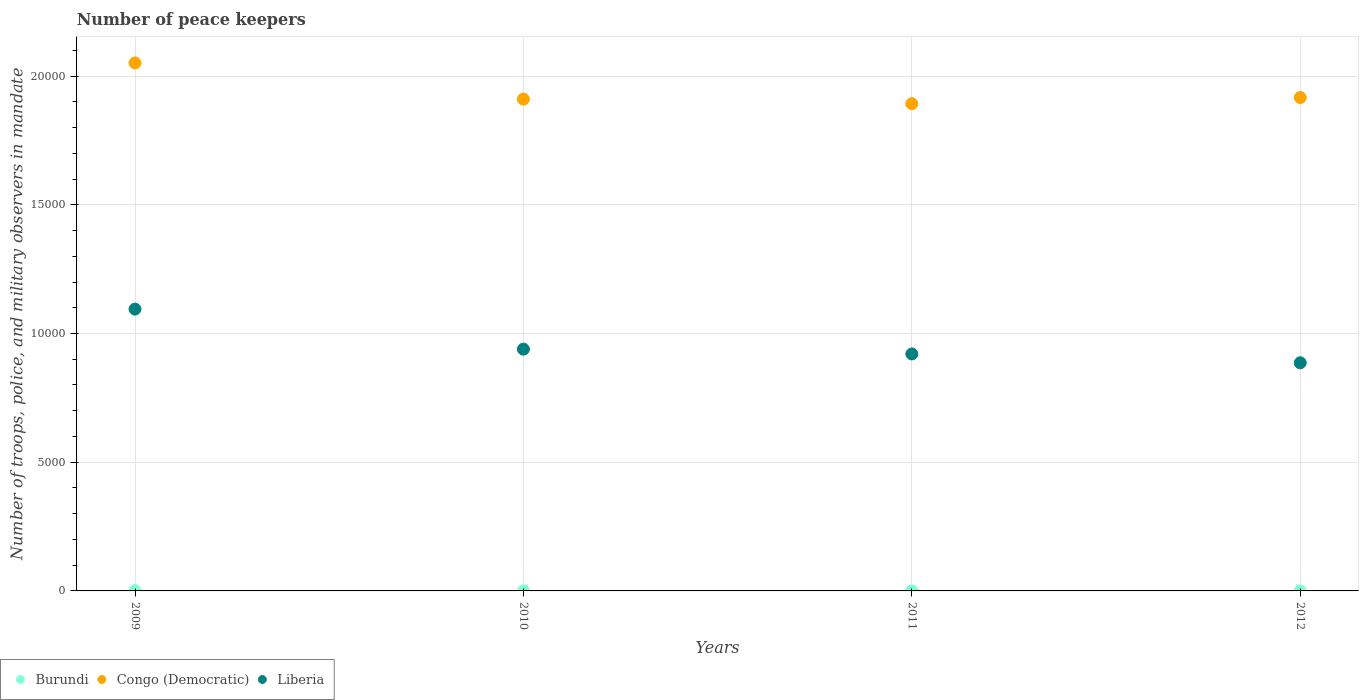Is the number of dotlines equal to the number of legend labels?
Your response must be concise. Yes. Across all years, what is the maximum number of peace keepers in in Liberia?
Provide a short and direct response. 1.09e+04. What is the total number of peace keepers in in Congo (Democratic) in the graph?
Offer a terse response. 7.77e+04. What is the difference between the number of peace keepers in in Burundi in 2009 and that in 2011?
Provide a succinct answer. 14. What is the difference between the number of peace keepers in in Congo (Democratic) in 2011 and the number of peace keepers in in Liberia in 2010?
Provide a short and direct response. 9536. What is the average number of peace keepers in in Congo (Democratic) per year?
Provide a short and direct response. 1.94e+04. In the year 2010, what is the difference between the number of peace keepers in in Burundi and number of peace keepers in in Liberia?
Provide a succinct answer. -9388. What is the ratio of the number of peace keepers in in Congo (Democratic) in 2009 to that in 2011?
Provide a succinct answer. 1.08. Is the number of peace keepers in in Burundi in 2010 less than that in 2012?
Your answer should be very brief. No. Is the difference between the number of peace keepers in in Burundi in 2009 and 2010 greater than the difference between the number of peace keepers in in Liberia in 2009 and 2010?
Provide a short and direct response. No. What is the difference between the highest and the second highest number of peace keepers in in Liberia?
Give a very brief answer. 1555. In how many years, is the number of peace keepers in in Burundi greater than the average number of peace keepers in in Burundi taken over all years?
Offer a terse response. 1. Is the sum of the number of peace keepers in in Liberia in 2011 and 2012 greater than the maximum number of peace keepers in in Congo (Democratic) across all years?
Keep it short and to the point. No. Does the number of peace keepers in in Liberia monotonically increase over the years?
Provide a short and direct response. No. Is the number of peace keepers in in Congo (Democratic) strictly greater than the number of peace keepers in in Burundi over the years?
Provide a short and direct response. Yes. How many dotlines are there?
Provide a short and direct response. 3. How many years are there in the graph?
Give a very brief answer. 4. Are the values on the major ticks of Y-axis written in scientific E-notation?
Keep it short and to the point. No. Does the graph contain grids?
Your answer should be very brief. Yes. How are the legend labels stacked?
Your response must be concise. Horizontal. What is the title of the graph?
Your answer should be very brief. Number of peace keepers. What is the label or title of the Y-axis?
Offer a terse response. Number of troops, police, and military observers in mandate. What is the Number of troops, police, and military observers in mandate of Burundi in 2009?
Keep it short and to the point. 15. What is the Number of troops, police, and military observers in mandate of Congo (Democratic) in 2009?
Provide a short and direct response. 2.05e+04. What is the Number of troops, police, and military observers in mandate of Liberia in 2009?
Keep it short and to the point. 1.09e+04. What is the Number of troops, police, and military observers in mandate of Congo (Democratic) in 2010?
Make the answer very short. 1.91e+04. What is the Number of troops, police, and military observers in mandate of Liberia in 2010?
Your answer should be compact. 9392. What is the Number of troops, police, and military observers in mandate of Congo (Democratic) in 2011?
Offer a terse response. 1.89e+04. What is the Number of troops, police, and military observers in mandate of Liberia in 2011?
Offer a terse response. 9206. What is the Number of troops, police, and military observers in mandate of Congo (Democratic) in 2012?
Your response must be concise. 1.92e+04. What is the Number of troops, police, and military observers in mandate in Liberia in 2012?
Your answer should be very brief. 8862. Across all years, what is the maximum Number of troops, police, and military observers in mandate of Congo (Democratic)?
Ensure brevity in your answer.  2.05e+04. Across all years, what is the maximum Number of troops, police, and military observers in mandate in Liberia?
Your response must be concise. 1.09e+04. Across all years, what is the minimum Number of troops, police, and military observers in mandate in Congo (Democratic)?
Give a very brief answer. 1.89e+04. Across all years, what is the minimum Number of troops, police, and military observers in mandate of Liberia?
Offer a terse response. 8862. What is the total Number of troops, police, and military observers in mandate in Congo (Democratic) in the graph?
Provide a short and direct response. 7.77e+04. What is the total Number of troops, police, and military observers in mandate of Liberia in the graph?
Make the answer very short. 3.84e+04. What is the difference between the Number of troops, police, and military observers in mandate of Congo (Democratic) in 2009 and that in 2010?
Offer a very short reply. 1404. What is the difference between the Number of troops, police, and military observers in mandate of Liberia in 2009 and that in 2010?
Make the answer very short. 1555. What is the difference between the Number of troops, police, and military observers in mandate of Burundi in 2009 and that in 2011?
Provide a succinct answer. 14. What is the difference between the Number of troops, police, and military observers in mandate in Congo (Democratic) in 2009 and that in 2011?
Offer a very short reply. 1581. What is the difference between the Number of troops, police, and military observers in mandate of Liberia in 2009 and that in 2011?
Offer a very short reply. 1741. What is the difference between the Number of troops, police, and military observers in mandate in Congo (Democratic) in 2009 and that in 2012?
Ensure brevity in your answer.  1343. What is the difference between the Number of troops, police, and military observers in mandate of Liberia in 2009 and that in 2012?
Your response must be concise. 2085. What is the difference between the Number of troops, police, and military observers in mandate in Burundi in 2010 and that in 2011?
Your answer should be very brief. 3. What is the difference between the Number of troops, police, and military observers in mandate in Congo (Democratic) in 2010 and that in 2011?
Offer a very short reply. 177. What is the difference between the Number of troops, police, and military observers in mandate in Liberia in 2010 and that in 2011?
Provide a short and direct response. 186. What is the difference between the Number of troops, police, and military observers in mandate in Congo (Democratic) in 2010 and that in 2012?
Ensure brevity in your answer.  -61. What is the difference between the Number of troops, police, and military observers in mandate in Liberia in 2010 and that in 2012?
Provide a succinct answer. 530. What is the difference between the Number of troops, police, and military observers in mandate in Burundi in 2011 and that in 2012?
Provide a short and direct response. -1. What is the difference between the Number of troops, police, and military observers in mandate of Congo (Democratic) in 2011 and that in 2012?
Your answer should be very brief. -238. What is the difference between the Number of troops, police, and military observers in mandate in Liberia in 2011 and that in 2012?
Give a very brief answer. 344. What is the difference between the Number of troops, police, and military observers in mandate of Burundi in 2009 and the Number of troops, police, and military observers in mandate of Congo (Democratic) in 2010?
Your answer should be compact. -1.91e+04. What is the difference between the Number of troops, police, and military observers in mandate in Burundi in 2009 and the Number of troops, police, and military observers in mandate in Liberia in 2010?
Your answer should be compact. -9377. What is the difference between the Number of troops, police, and military observers in mandate in Congo (Democratic) in 2009 and the Number of troops, police, and military observers in mandate in Liberia in 2010?
Provide a succinct answer. 1.11e+04. What is the difference between the Number of troops, police, and military observers in mandate of Burundi in 2009 and the Number of troops, police, and military observers in mandate of Congo (Democratic) in 2011?
Provide a succinct answer. -1.89e+04. What is the difference between the Number of troops, police, and military observers in mandate of Burundi in 2009 and the Number of troops, police, and military observers in mandate of Liberia in 2011?
Provide a succinct answer. -9191. What is the difference between the Number of troops, police, and military observers in mandate in Congo (Democratic) in 2009 and the Number of troops, police, and military observers in mandate in Liberia in 2011?
Your response must be concise. 1.13e+04. What is the difference between the Number of troops, police, and military observers in mandate of Burundi in 2009 and the Number of troops, police, and military observers in mandate of Congo (Democratic) in 2012?
Offer a very short reply. -1.92e+04. What is the difference between the Number of troops, police, and military observers in mandate of Burundi in 2009 and the Number of troops, police, and military observers in mandate of Liberia in 2012?
Your answer should be compact. -8847. What is the difference between the Number of troops, police, and military observers in mandate of Congo (Democratic) in 2009 and the Number of troops, police, and military observers in mandate of Liberia in 2012?
Ensure brevity in your answer.  1.16e+04. What is the difference between the Number of troops, police, and military observers in mandate of Burundi in 2010 and the Number of troops, police, and military observers in mandate of Congo (Democratic) in 2011?
Provide a short and direct response. -1.89e+04. What is the difference between the Number of troops, police, and military observers in mandate in Burundi in 2010 and the Number of troops, police, and military observers in mandate in Liberia in 2011?
Your response must be concise. -9202. What is the difference between the Number of troops, police, and military observers in mandate in Congo (Democratic) in 2010 and the Number of troops, police, and military observers in mandate in Liberia in 2011?
Provide a short and direct response. 9899. What is the difference between the Number of troops, police, and military observers in mandate in Burundi in 2010 and the Number of troops, police, and military observers in mandate in Congo (Democratic) in 2012?
Your response must be concise. -1.92e+04. What is the difference between the Number of troops, police, and military observers in mandate of Burundi in 2010 and the Number of troops, police, and military observers in mandate of Liberia in 2012?
Make the answer very short. -8858. What is the difference between the Number of troops, police, and military observers in mandate in Congo (Democratic) in 2010 and the Number of troops, police, and military observers in mandate in Liberia in 2012?
Make the answer very short. 1.02e+04. What is the difference between the Number of troops, police, and military observers in mandate of Burundi in 2011 and the Number of troops, police, and military observers in mandate of Congo (Democratic) in 2012?
Offer a terse response. -1.92e+04. What is the difference between the Number of troops, police, and military observers in mandate of Burundi in 2011 and the Number of troops, police, and military observers in mandate of Liberia in 2012?
Offer a very short reply. -8861. What is the difference between the Number of troops, police, and military observers in mandate in Congo (Democratic) in 2011 and the Number of troops, police, and military observers in mandate in Liberia in 2012?
Your answer should be very brief. 1.01e+04. What is the average Number of troops, police, and military observers in mandate in Burundi per year?
Your response must be concise. 5.5. What is the average Number of troops, police, and military observers in mandate in Congo (Democratic) per year?
Make the answer very short. 1.94e+04. What is the average Number of troops, police, and military observers in mandate of Liberia per year?
Your response must be concise. 9601.75. In the year 2009, what is the difference between the Number of troops, police, and military observers in mandate of Burundi and Number of troops, police, and military observers in mandate of Congo (Democratic)?
Provide a succinct answer. -2.05e+04. In the year 2009, what is the difference between the Number of troops, police, and military observers in mandate in Burundi and Number of troops, police, and military observers in mandate in Liberia?
Give a very brief answer. -1.09e+04. In the year 2009, what is the difference between the Number of troops, police, and military observers in mandate in Congo (Democratic) and Number of troops, police, and military observers in mandate in Liberia?
Keep it short and to the point. 9562. In the year 2010, what is the difference between the Number of troops, police, and military observers in mandate of Burundi and Number of troops, police, and military observers in mandate of Congo (Democratic)?
Your answer should be compact. -1.91e+04. In the year 2010, what is the difference between the Number of troops, police, and military observers in mandate of Burundi and Number of troops, police, and military observers in mandate of Liberia?
Provide a succinct answer. -9388. In the year 2010, what is the difference between the Number of troops, police, and military observers in mandate in Congo (Democratic) and Number of troops, police, and military observers in mandate in Liberia?
Provide a short and direct response. 9713. In the year 2011, what is the difference between the Number of troops, police, and military observers in mandate of Burundi and Number of troops, police, and military observers in mandate of Congo (Democratic)?
Give a very brief answer. -1.89e+04. In the year 2011, what is the difference between the Number of troops, police, and military observers in mandate in Burundi and Number of troops, police, and military observers in mandate in Liberia?
Provide a short and direct response. -9205. In the year 2011, what is the difference between the Number of troops, police, and military observers in mandate of Congo (Democratic) and Number of troops, police, and military observers in mandate of Liberia?
Ensure brevity in your answer.  9722. In the year 2012, what is the difference between the Number of troops, police, and military observers in mandate of Burundi and Number of troops, police, and military observers in mandate of Congo (Democratic)?
Offer a very short reply. -1.92e+04. In the year 2012, what is the difference between the Number of troops, police, and military observers in mandate in Burundi and Number of troops, police, and military observers in mandate in Liberia?
Your response must be concise. -8860. In the year 2012, what is the difference between the Number of troops, police, and military observers in mandate in Congo (Democratic) and Number of troops, police, and military observers in mandate in Liberia?
Ensure brevity in your answer.  1.03e+04. What is the ratio of the Number of troops, police, and military observers in mandate in Burundi in 2009 to that in 2010?
Your answer should be very brief. 3.75. What is the ratio of the Number of troops, police, and military observers in mandate in Congo (Democratic) in 2009 to that in 2010?
Keep it short and to the point. 1.07. What is the ratio of the Number of troops, police, and military observers in mandate in Liberia in 2009 to that in 2010?
Offer a terse response. 1.17. What is the ratio of the Number of troops, police, and military observers in mandate of Congo (Democratic) in 2009 to that in 2011?
Your answer should be very brief. 1.08. What is the ratio of the Number of troops, police, and military observers in mandate in Liberia in 2009 to that in 2011?
Your response must be concise. 1.19. What is the ratio of the Number of troops, police, and military observers in mandate of Congo (Democratic) in 2009 to that in 2012?
Your answer should be compact. 1.07. What is the ratio of the Number of troops, police, and military observers in mandate in Liberia in 2009 to that in 2012?
Ensure brevity in your answer.  1.24. What is the ratio of the Number of troops, police, and military observers in mandate in Congo (Democratic) in 2010 to that in 2011?
Offer a terse response. 1.01. What is the ratio of the Number of troops, police, and military observers in mandate in Liberia in 2010 to that in 2011?
Keep it short and to the point. 1.02. What is the ratio of the Number of troops, police, and military observers in mandate in Burundi in 2010 to that in 2012?
Offer a very short reply. 2. What is the ratio of the Number of troops, police, and military observers in mandate of Liberia in 2010 to that in 2012?
Ensure brevity in your answer.  1.06. What is the ratio of the Number of troops, police, and military observers in mandate in Burundi in 2011 to that in 2012?
Keep it short and to the point. 0.5. What is the ratio of the Number of troops, police, and military observers in mandate of Congo (Democratic) in 2011 to that in 2012?
Offer a terse response. 0.99. What is the ratio of the Number of troops, police, and military observers in mandate in Liberia in 2011 to that in 2012?
Make the answer very short. 1.04. What is the difference between the highest and the second highest Number of troops, police, and military observers in mandate of Congo (Democratic)?
Provide a short and direct response. 1343. What is the difference between the highest and the second highest Number of troops, police, and military observers in mandate of Liberia?
Give a very brief answer. 1555. What is the difference between the highest and the lowest Number of troops, police, and military observers in mandate of Congo (Democratic)?
Offer a very short reply. 1581. What is the difference between the highest and the lowest Number of troops, police, and military observers in mandate in Liberia?
Offer a terse response. 2085. 